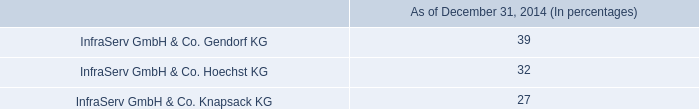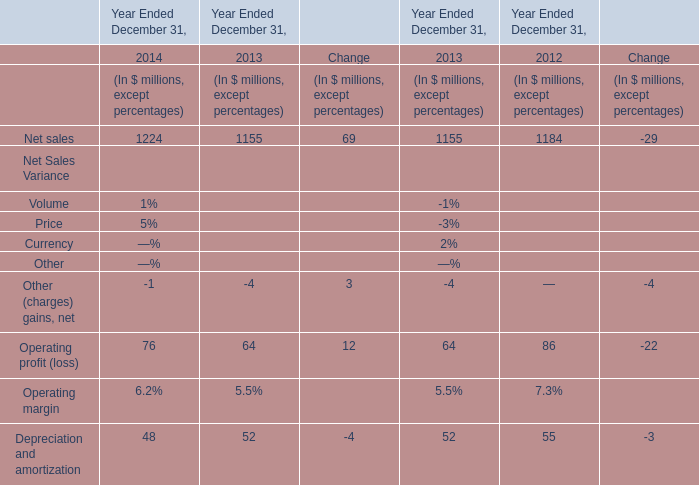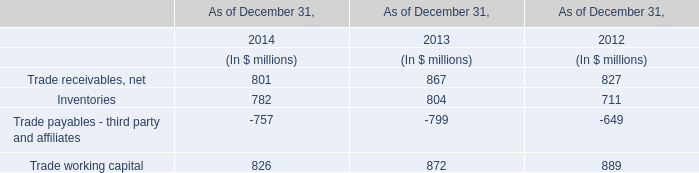what was the percentage growth of the cash dividends from 2012 to 2014 
Computations: ((115 - 83) / 83)
Answer: 0.38554. 